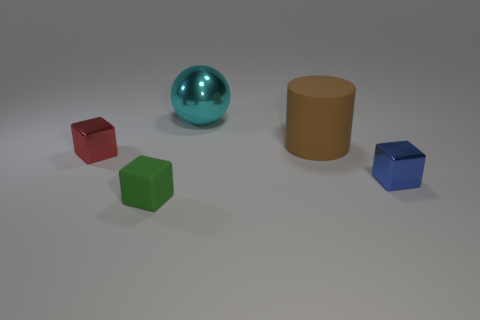Add 1 metallic blocks. How many objects exist? 6 Subtract all spheres. How many objects are left? 4 Add 2 small rubber blocks. How many small rubber blocks are left? 3 Add 3 small red things. How many small red things exist? 4 Subtract 0 yellow balls. How many objects are left? 5 Subtract all big rubber cylinders. Subtract all tiny blue blocks. How many objects are left? 3 